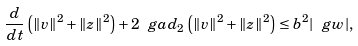<formula> <loc_0><loc_0><loc_500><loc_500>\frac { d } { d t } \left ( \| v \| ^ { 2 } + \| z \| ^ { 2 } \right ) + 2 \ g a d _ { 2 } \left ( \| v \| ^ { 2 } + \| z \| ^ { 2 } \right ) \leq b ^ { 2 } | \ g w | ,</formula> 